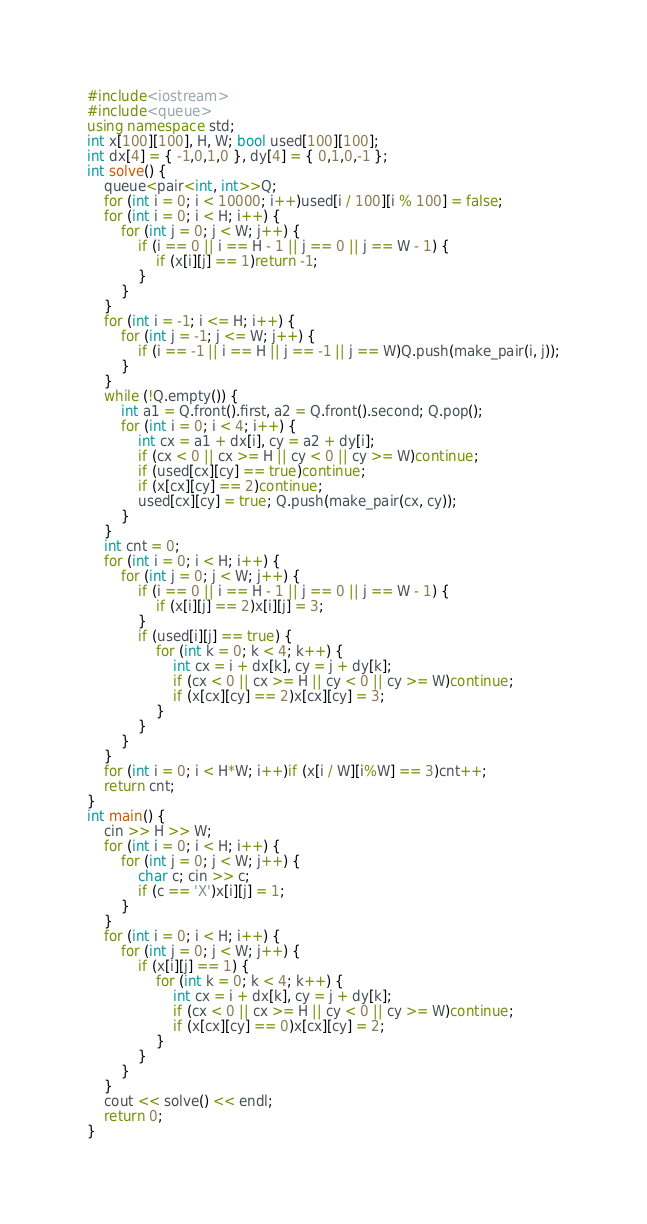<code> <loc_0><loc_0><loc_500><loc_500><_C++_>#include<iostream>
#include<queue>
using namespace std;
int x[100][100], H, W; bool used[100][100];
int dx[4] = { -1,0,1,0 }, dy[4] = { 0,1,0,-1 };
int solve() {
	queue<pair<int, int>>Q;
	for (int i = 0; i < 10000; i++)used[i / 100][i % 100] = false;
	for (int i = 0; i < H; i++) {
		for (int j = 0; j < W; j++) {
			if (i == 0 || i == H - 1 || j == 0 || j == W - 1) {
				if (x[i][j] == 1)return -1;
			}
		}
	}
	for (int i = -1; i <= H; i++) {
		for (int j = -1; j <= W; j++) {
			if (i == -1 || i == H || j == -1 || j == W)Q.push(make_pair(i, j));
		}
	}
	while (!Q.empty()) {
		int a1 = Q.front().first, a2 = Q.front().second; Q.pop();
		for (int i = 0; i < 4; i++) {
			int cx = a1 + dx[i], cy = a2 + dy[i];
			if (cx < 0 || cx >= H || cy < 0 || cy >= W)continue;
			if (used[cx][cy] == true)continue;
			if (x[cx][cy] == 2)continue;
			used[cx][cy] = true; Q.push(make_pair(cx, cy));
		}
	}
	int cnt = 0;
	for (int i = 0; i < H; i++) {
		for (int j = 0; j < W; j++) {
			if (i == 0 || i == H - 1 || j == 0 || j == W - 1) {
				if (x[i][j] == 2)x[i][j] = 3;
			}
			if (used[i][j] == true) {
				for (int k = 0; k < 4; k++) {
					int cx = i + dx[k], cy = j + dy[k];
					if (cx < 0 || cx >= H || cy < 0 || cy >= W)continue;
					if (x[cx][cy] == 2)x[cx][cy] = 3;
				}
			}
		}
	}
	for (int i = 0; i < H*W; i++)if (x[i / W][i%W] == 3)cnt++;
	return cnt;
}
int main() {
	cin >> H >> W;
	for (int i = 0; i < H; i++) {
		for (int j = 0; j < W; j++) {
			char c; cin >> c;
			if (c == 'X')x[i][j] = 1;
		}
	}
	for (int i = 0; i < H; i++) {
		for (int j = 0; j < W; j++) {
			if (x[i][j] == 1) {
				for (int k = 0; k < 4; k++) {
					int cx = i + dx[k], cy = j + dy[k];
					if (cx < 0 || cx >= H || cy < 0 || cy >= W)continue;
					if (x[cx][cy] == 0)x[cx][cy] = 2;
				}
			}
		}
	}
	cout << solve() << endl;
	return 0;
}</code> 